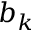Convert formula to latex. <formula><loc_0><loc_0><loc_500><loc_500>b _ { k }</formula> 